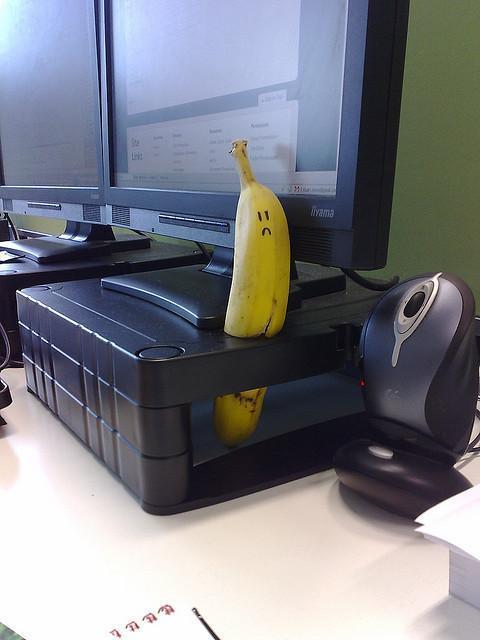How many mice are visible?
Give a very brief answer. 2. How many tvs are there?
Give a very brief answer. 2. How many bananas are visible?
Give a very brief answer. 1. 